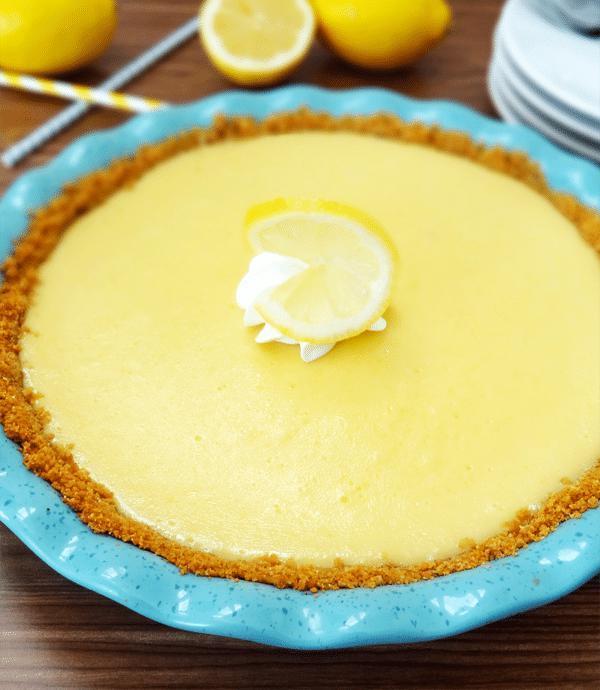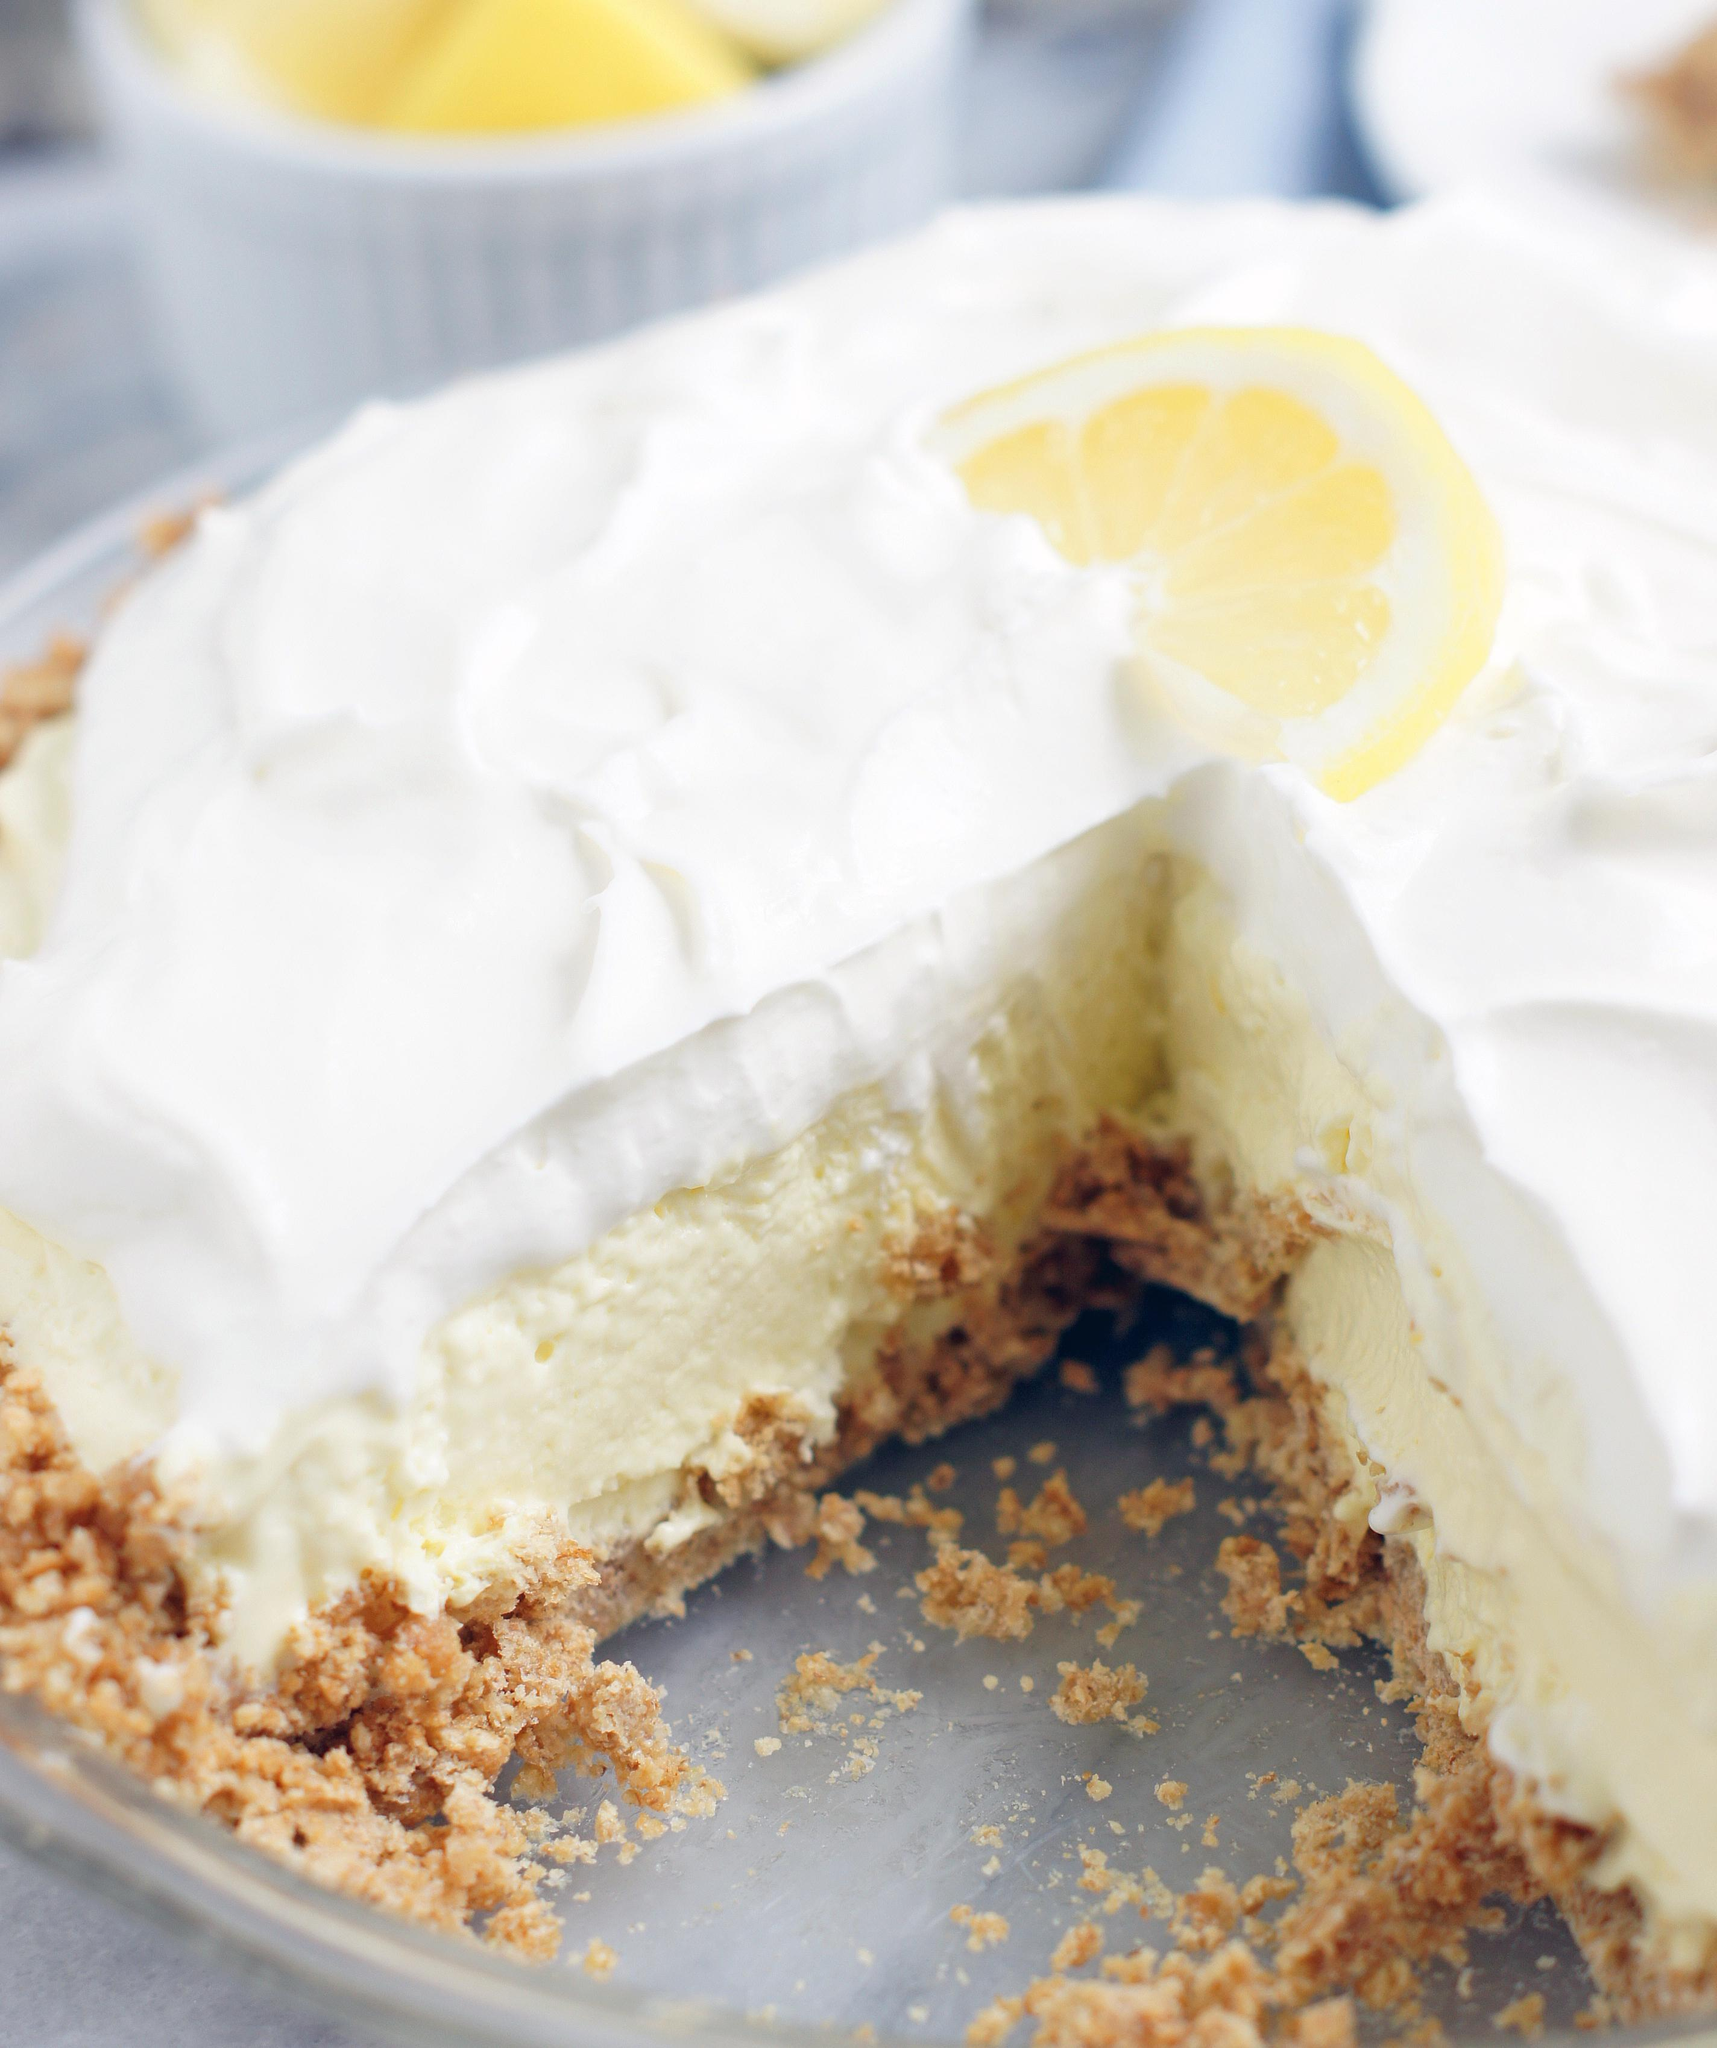The first image is the image on the left, the second image is the image on the right. Analyze the images presented: Is the assertion "There is one whole pie." valid? Answer yes or no. Yes. The first image is the image on the left, the second image is the image on the right. Examine the images to the left and right. Is the description "The left image shows one pie slice on a white plate, and the right image shows a pie with a slice missing and includes an individual slice." accurate? Answer yes or no. No. 